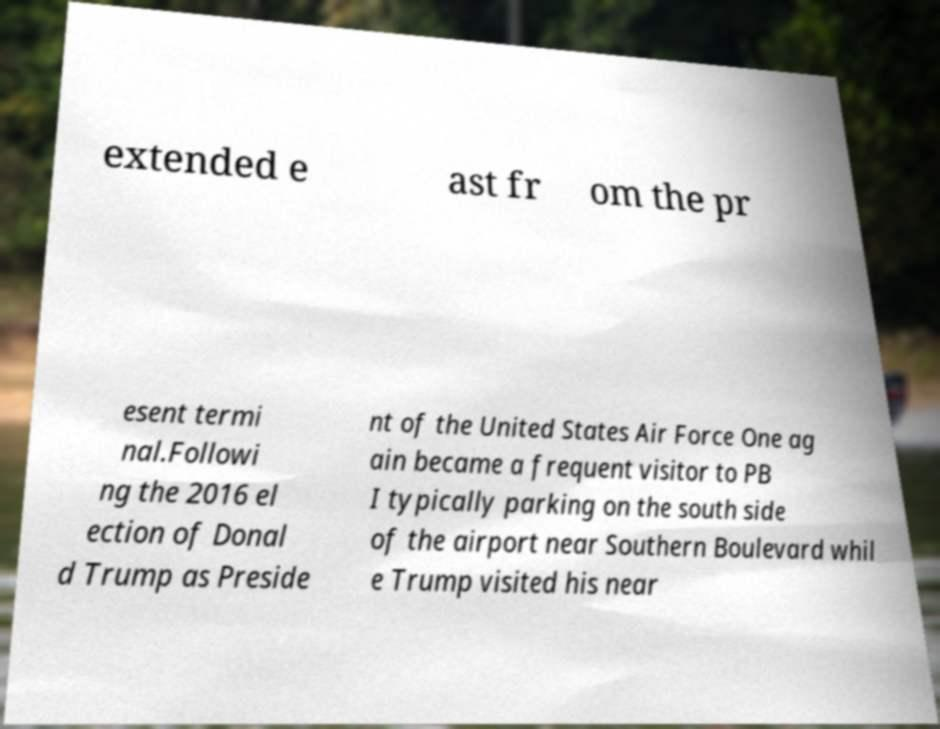For documentation purposes, I need the text within this image transcribed. Could you provide that? extended e ast fr om the pr esent termi nal.Followi ng the 2016 el ection of Donal d Trump as Preside nt of the United States Air Force One ag ain became a frequent visitor to PB I typically parking on the south side of the airport near Southern Boulevard whil e Trump visited his near 